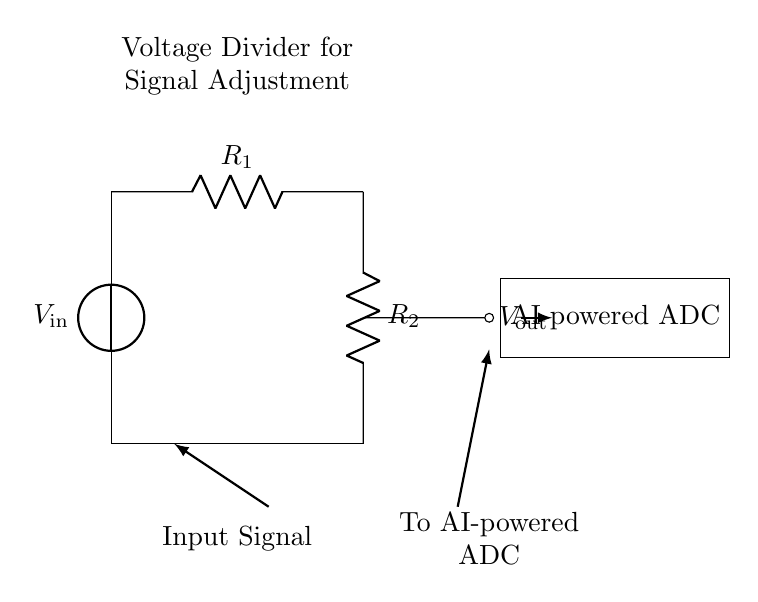What is the input voltage in the circuit? The input voltage is labeled as V_in, which is the source voltage provided to the circuit.
Answer: V_in What are the resistor values used in the voltage divider? The circuit has two resistors, R_1 and R_2, whose values are specified in the diagram to create a voltage divider.
Answer: R_1, R_2 What is the output voltage in the circuit? The output voltage, V_out, is indicated at the midpoint between the resistors R_1 and R_2, which divides the input voltage according to the resistor values.
Answer: V_out How does the voltage divider affect the signal sent to the AI-powered ADC? The voltage divider adjusts the input signal to a level suitable for the AI-powered analog-to-digital converter, ensuring proper operation without overloading the ADC's input.
Answer: It adjusts the signal What is the purpose of R_1 and R_2 in the circuit? Resistors R_1 and R_2 create a voltage proportionate division of the input voltage V_in, enabling the desired output voltage V_out to be fed into the AI-powered ADC.
Answer: To divide voltage If R_1 is twice the value of R_2, what will be the relationship between V_out and V_in? The relationship can be derived using the voltage divider rule: V_out equals one-third of V_in when R_1 is twice R_2, meaning V_out = V_in / 3.
Answer: V_out = V_in / 3 